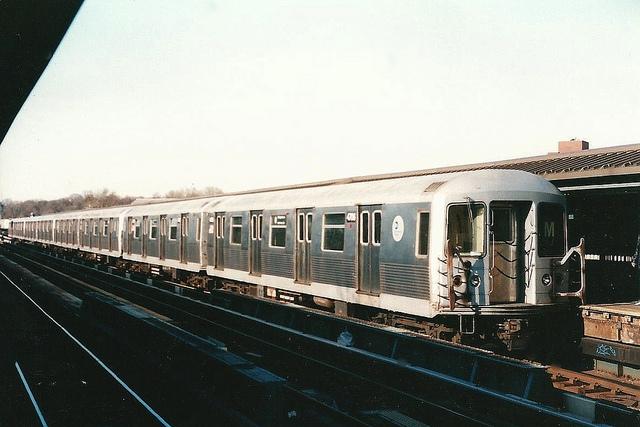What is high over the trees in the background?
Write a very short answer. Sky. Is this a passenger train?
Short answer required. Yes. How many trains are visible?
Give a very brief answer. 1. What color is the train?
Give a very brief answer. Silver. Is the train in motion?
Give a very brief answer. No. 